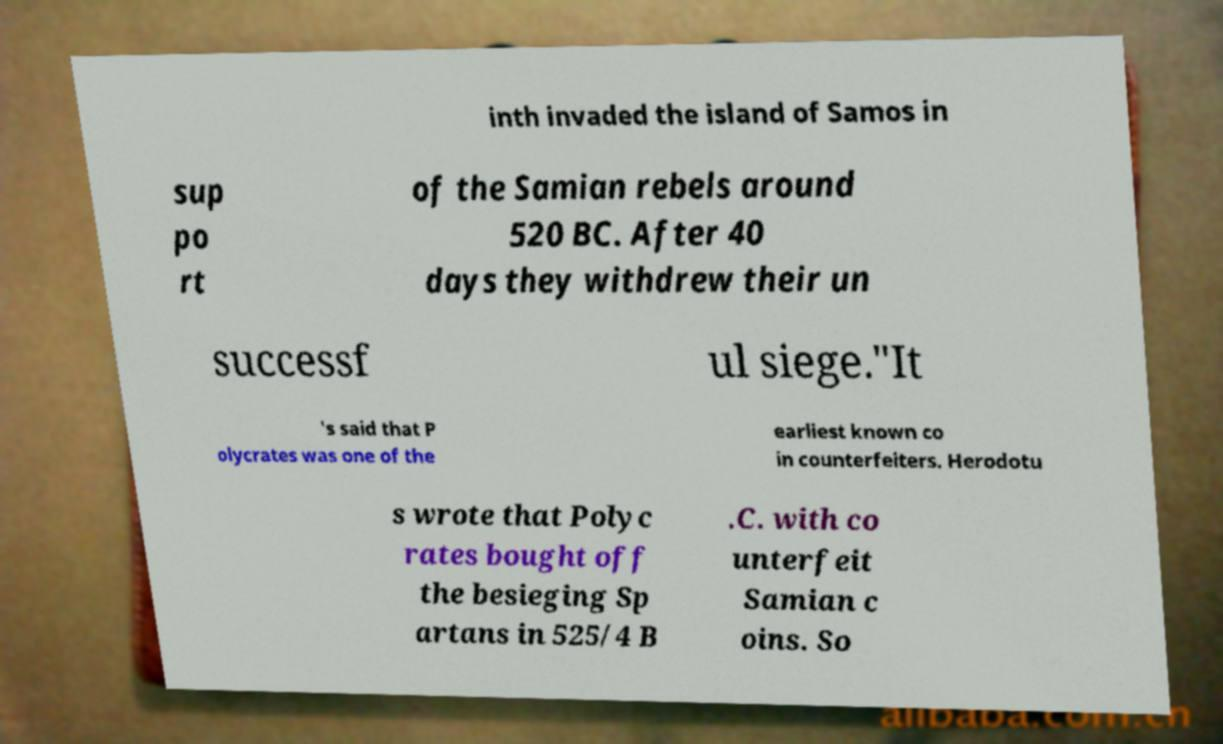What messages or text are displayed in this image? I need them in a readable, typed format. inth invaded the island of Samos in sup po rt of the Samian rebels around 520 BC. After 40 days they withdrew their un successf ul siege."It 's said that P olycrates was one of the earliest known co in counterfeiters. Herodotu s wrote that Polyc rates bought off the besieging Sp artans in 525/4 B .C. with co unterfeit Samian c oins. So 